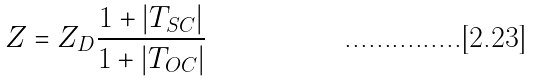<formula> <loc_0><loc_0><loc_500><loc_500>Z = Z _ { D } \frac { 1 + | T _ { S C } | } { 1 + | T _ { O C } | }</formula> 